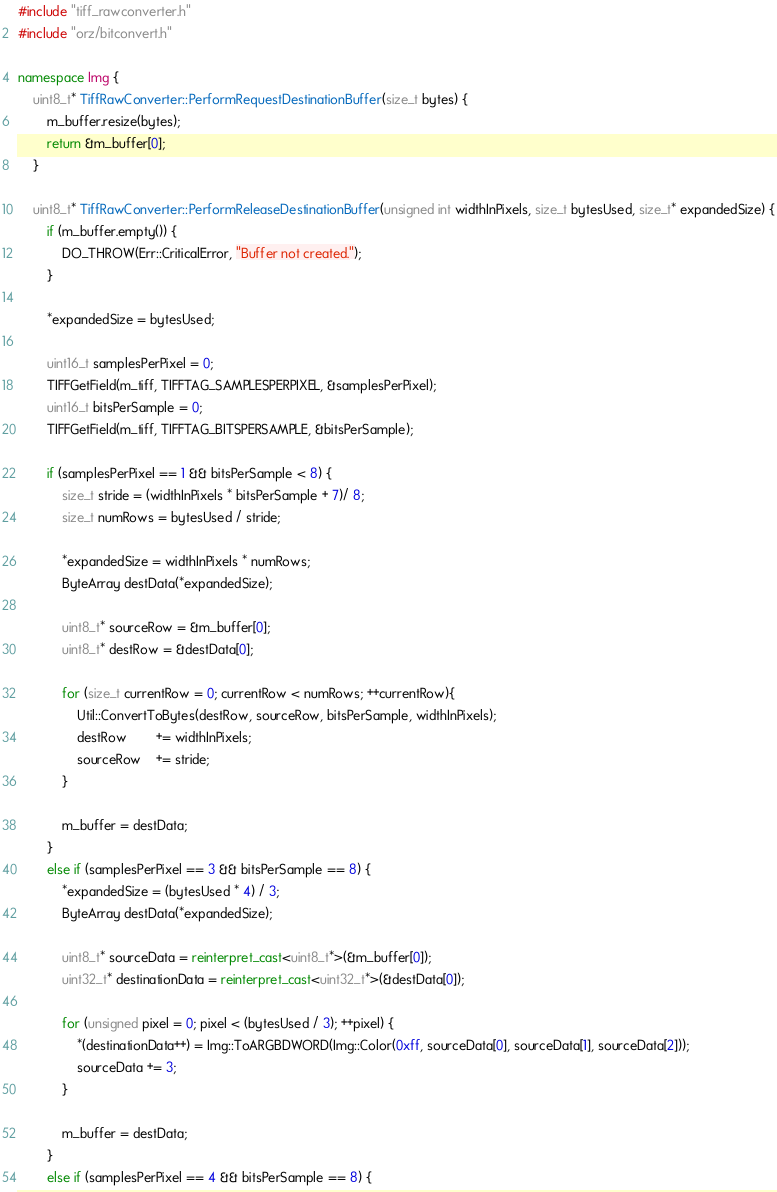Convert code to text. <code><loc_0><loc_0><loc_500><loc_500><_C++_>#include "tiff_rawconverter.h"
#include "orz/bitconvert.h"

namespace Img {
	uint8_t* TiffRawConverter::PerformRequestDestinationBuffer(size_t bytes) {
		m_buffer.resize(bytes);
		return &m_buffer[0];
	}

	uint8_t* TiffRawConverter::PerformReleaseDestinationBuffer(unsigned int widthInPixels, size_t bytesUsed, size_t* expandedSize) {
		if (m_buffer.empty()) {
			DO_THROW(Err::CriticalError, "Buffer not created.");
		}

		*expandedSize = bytesUsed;

		uint16_t samplesPerPixel = 0;
		TIFFGetField(m_tiff, TIFFTAG_SAMPLESPERPIXEL, &samplesPerPixel);
		uint16_t bitsPerSample = 0;
		TIFFGetField(m_tiff, TIFFTAG_BITSPERSAMPLE, &bitsPerSample);

		if (samplesPerPixel == 1 && bitsPerSample < 8) {
			size_t stride = (widthInPixels * bitsPerSample + 7)/ 8;
			size_t numRows = bytesUsed / stride;

			*expandedSize = widthInPixels * numRows;
			ByteArray destData(*expandedSize);

			uint8_t* sourceRow = &m_buffer[0];
			uint8_t* destRow = &destData[0];

			for (size_t currentRow = 0; currentRow < numRows; ++currentRow){
				Util::ConvertToBytes(destRow, sourceRow, bitsPerSample, widthInPixels);
				destRow		+= widthInPixels;
				sourceRow	+= stride;
			}

			m_buffer = destData;
		}
		else if (samplesPerPixel == 3 && bitsPerSample == 8) {
			*expandedSize = (bytesUsed * 4) / 3;
			ByteArray destData(*expandedSize);

			uint8_t* sourceData = reinterpret_cast<uint8_t*>(&m_buffer[0]);
			uint32_t* destinationData = reinterpret_cast<uint32_t*>(&destData[0]);

			for (unsigned pixel = 0; pixel < (bytesUsed / 3); ++pixel) {
				*(destinationData++) = Img::ToARGBDWORD(Img::Color(0xff, sourceData[0], sourceData[1], sourceData[2]));
				sourceData += 3;
			}

			m_buffer = destData;
		}
		else if (samplesPerPixel == 4 && bitsPerSample == 8) {</code> 